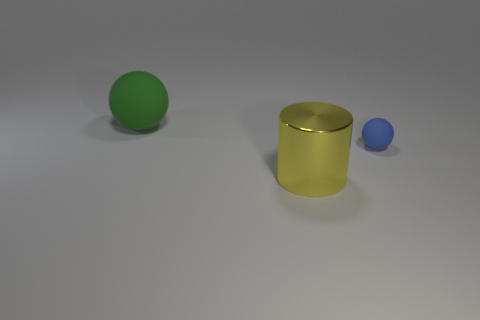Is there anything else that is the same material as the large yellow thing?
Your response must be concise. No. There is a sphere that is on the left side of the matte object on the right side of the matte thing that is to the left of the blue rubber ball; how big is it?
Your answer should be compact. Large. Are there any big yellow metal cylinders on the right side of the big yellow shiny object?
Make the answer very short. No. Does the yellow object have the same size as the object to the right of the yellow object?
Ensure brevity in your answer.  No. What number of other objects are the same material as the blue object?
Make the answer very short. 1. There is a object that is in front of the big ball and behind the shiny cylinder; what is its shape?
Provide a short and direct response. Sphere. Does the matte object that is on the right side of the green rubber sphere have the same size as the matte sphere on the left side of the large metallic cylinder?
Give a very brief answer. No. There is another green object that is made of the same material as the tiny object; what is its shape?
Make the answer very short. Sphere. Are there any other things that have the same shape as the yellow shiny object?
Ensure brevity in your answer.  No. What color is the matte thing in front of the matte thing that is to the left of the large object that is on the right side of the green thing?
Provide a succinct answer. Blue. 